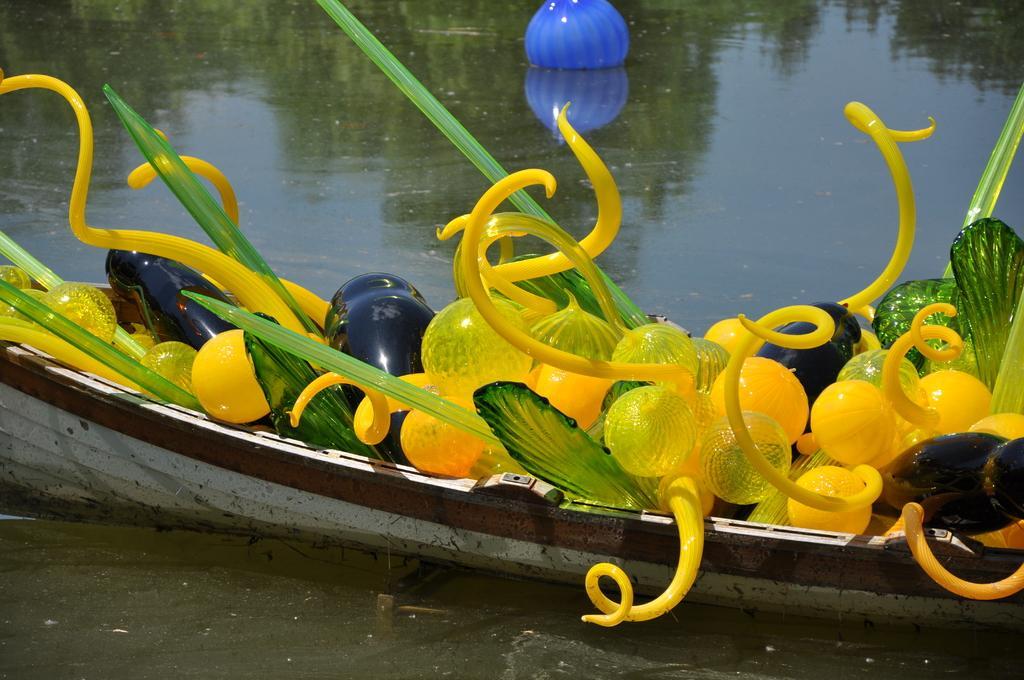Please provide a concise description of this image. In the picture I can see a boat which is on the water and there are few objects which are in different colors are placed in it. 